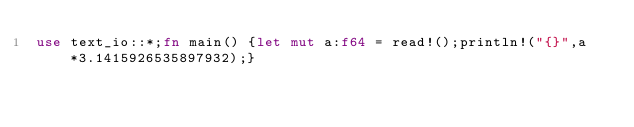Convert code to text. <code><loc_0><loc_0><loc_500><loc_500><_Rust_>use text_io::*;fn main() {let mut a:f64 = read!();println!("{}",a*3.1415926535897932);}</code> 